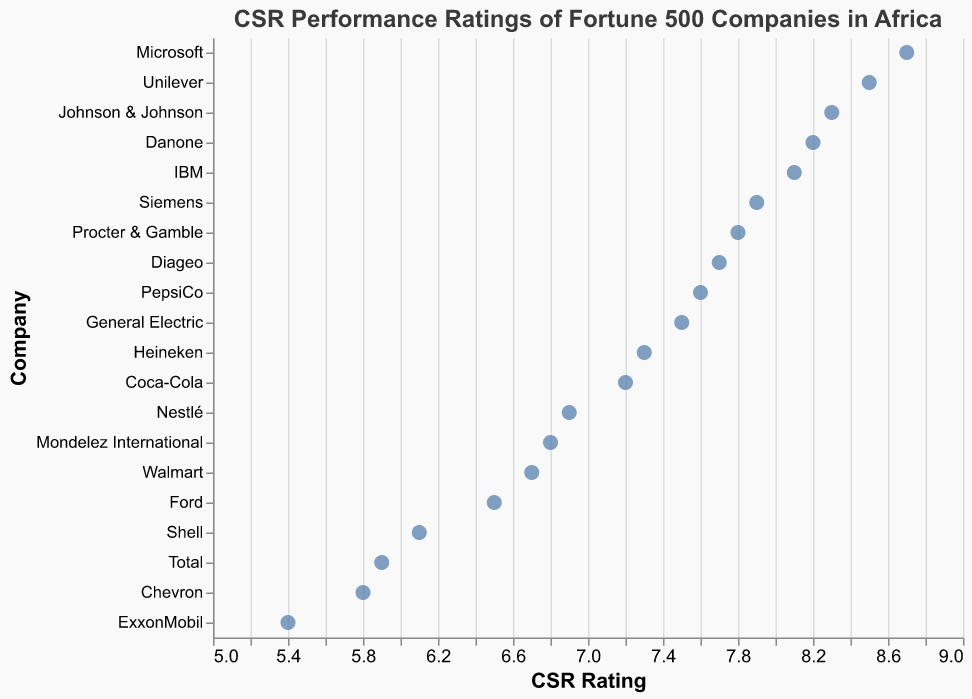What is the title of the plot? The title is located at the top of the plot and describes the content of the figure.
Answer: CSR Performance Ratings of Fortune 500 Companies in Africa Which company has the highest CSR rating? The highest rating can be found at the furthest right point on the x-axis.
Answer: Microsoft Which company has the lowest CSR rating? The lowest rating can be found at the furthest left point on the x-axis.
Answer: ExxonMobil What is the CSR rating of Procter & Gamble? Locate the point corresponding to Procter & Gamble on the y-axis and read the value on the x-axis.
Answer: 7.8 How many companies have a CSR rating above 8? Count the number of data points that lie above the value of 8 on the x-axis.
Answer: 6 What is the difference in CSR rating between Shell and Johnson & Johnson? Subtract Shell's CSR rating from Johnson & Johnson’s CSR rating (8.3 - 6.1).
Answer: 2.2 What is the average CSR rating of Coca-Cola, Unilever, and Nestlé? Add the CSR ratings of the three companies and divide by 3: (7.2 + 8.5 + 6.9) / 3 = 7.53.
Answer: 7.53 What is the range of the CSR ratings (difference between highest and lowest ratings)? Subtract the lowest CSR rating from the highest CSR rating (8.7 - 5.4).
Answer: 3.3 Which three companies have the closest CSR ratings? Find three companies whose CSR ratings are closest in value, which is Siemens (7.9), Procter & Gamble (7.8), and Diageo (7.7).
Answer: Siemens, Procter & Gamble, Diageo Is there any company with a CSR rating exactly at 6.5? If so, which one? Look at the points corresponding to the CSR rating of 6.5 on the x-axis and identify the company on the y-axis.
Answer: Ford 